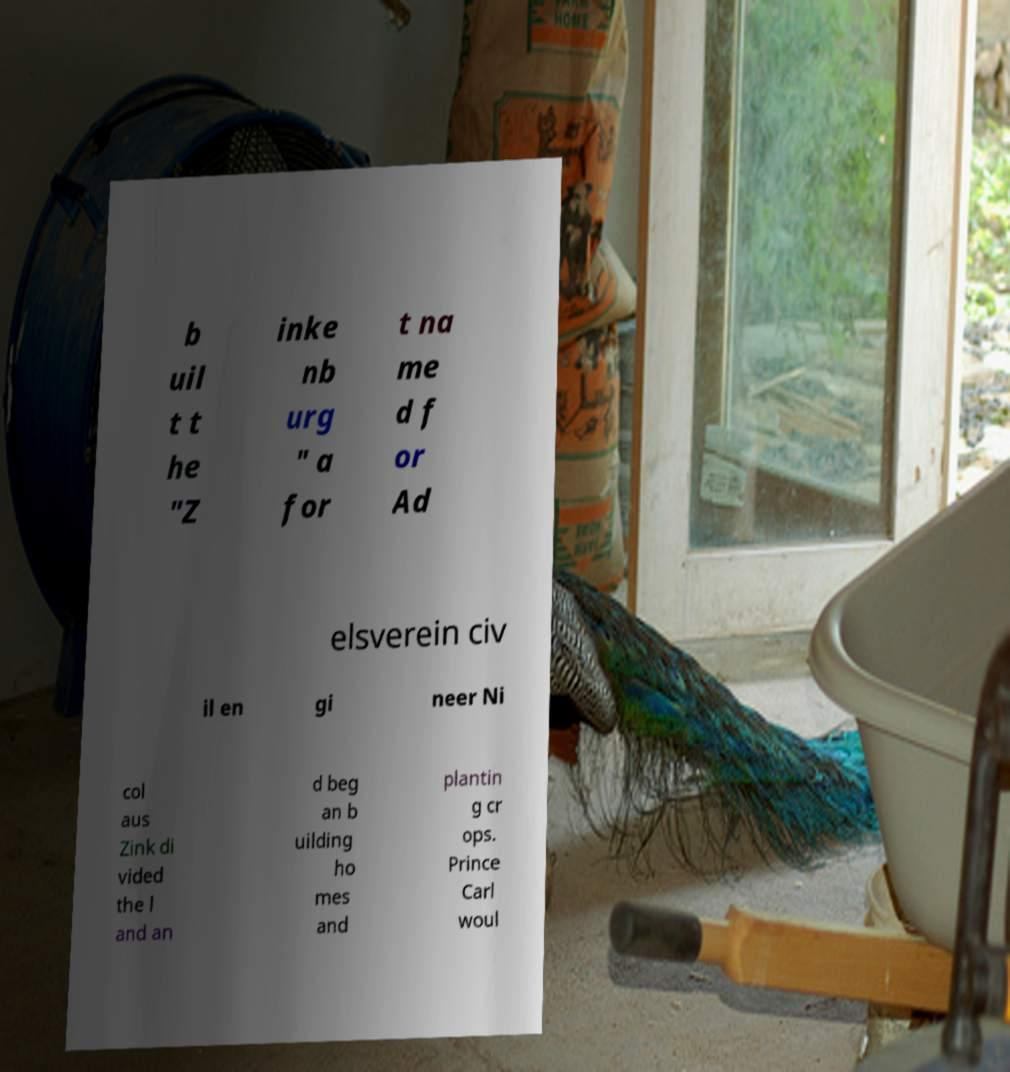Please identify and transcribe the text found in this image. b uil t t he "Z inke nb urg " a for t na me d f or Ad elsverein civ il en gi neer Ni col aus Zink di vided the l and an d beg an b uilding ho mes and plantin g cr ops. Prince Carl woul 